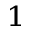Convert formula to latex. <formula><loc_0><loc_0><loc_500><loc_500>^ { 1 }</formula> 